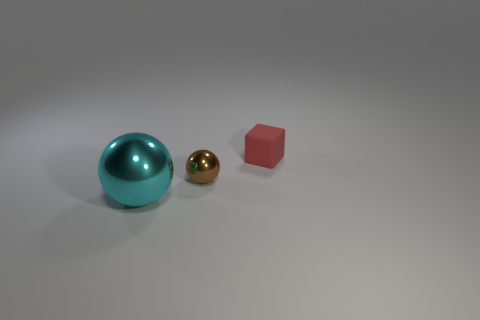Add 2 large things. How many objects exist? 5 Subtract all cubes. How many objects are left? 2 Subtract all small yellow matte cubes. Subtract all matte blocks. How many objects are left? 2 Add 2 tiny red matte cubes. How many tiny red matte cubes are left? 3 Add 1 tiny green shiny cubes. How many tiny green shiny cubes exist? 1 Subtract 0 green blocks. How many objects are left? 3 